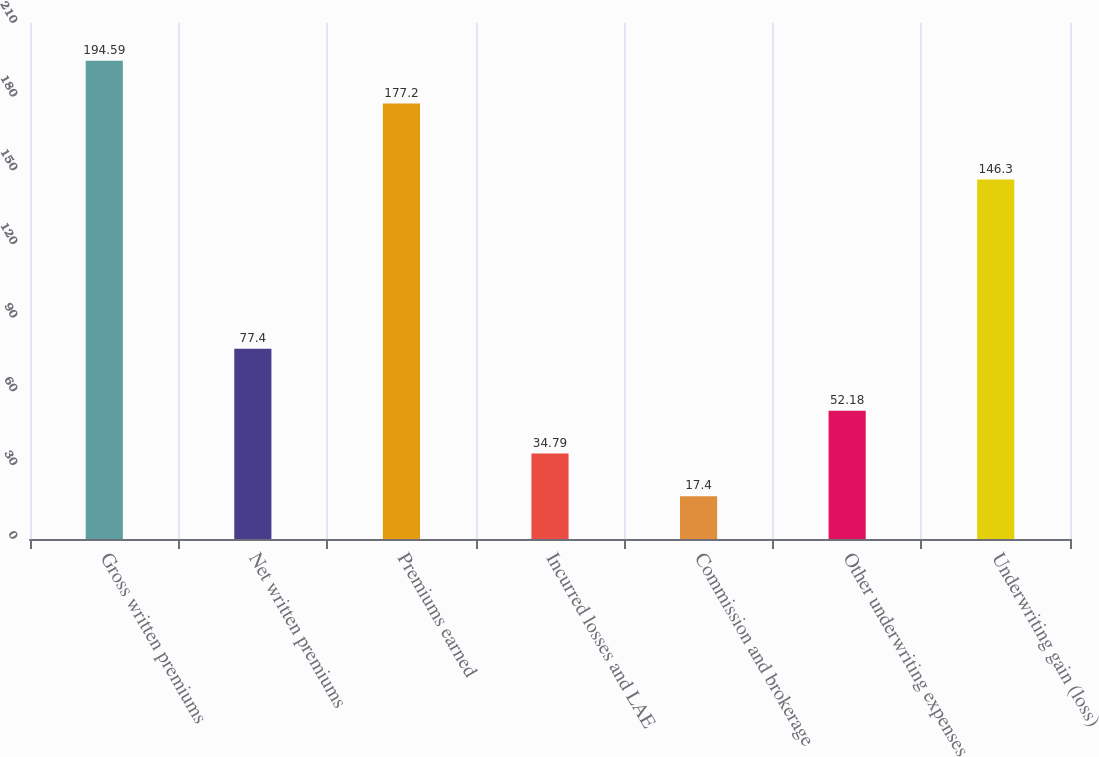Convert chart. <chart><loc_0><loc_0><loc_500><loc_500><bar_chart><fcel>Gross written premiums<fcel>Net written premiums<fcel>Premiums earned<fcel>Incurred losses and LAE<fcel>Commission and brokerage<fcel>Other underwriting expenses<fcel>Underwriting gain (loss)<nl><fcel>194.59<fcel>77.4<fcel>177.2<fcel>34.79<fcel>17.4<fcel>52.18<fcel>146.3<nl></chart> 